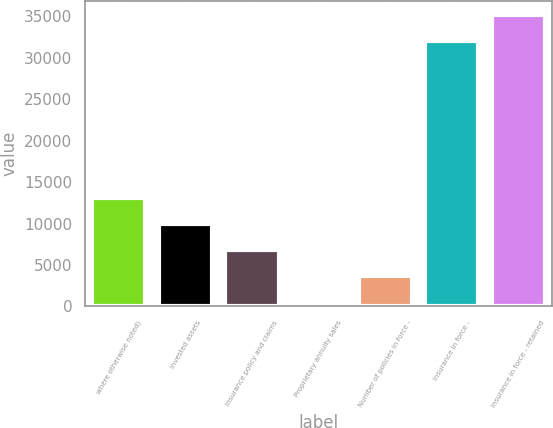<chart> <loc_0><loc_0><loc_500><loc_500><bar_chart><fcel>where otherwise noted)<fcel>Invested assets<fcel>Insurance policy and claims<fcel>Proprietary annuity sales<fcel>Number of policies in force -<fcel>Insurance in force -<fcel>Insurance in force - retained<nl><fcel>13125.6<fcel>9981.2<fcel>6836.8<fcel>548<fcel>3692.4<fcel>31992<fcel>35136.4<nl></chart> 